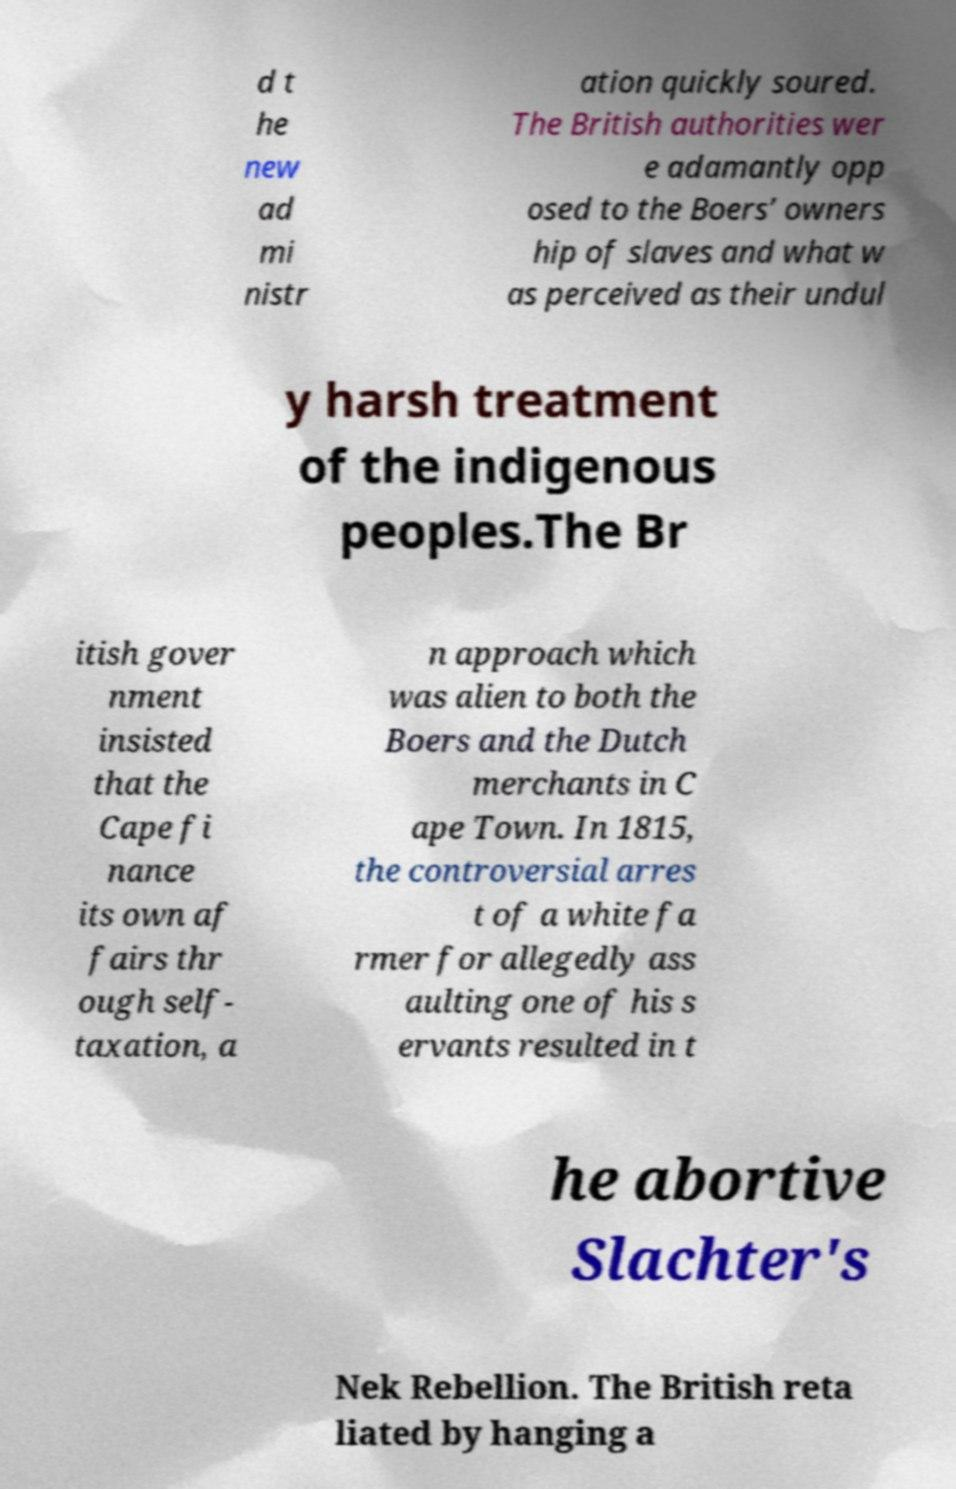For documentation purposes, I need the text within this image transcribed. Could you provide that? d t he new ad mi nistr ation quickly soured. The British authorities wer e adamantly opp osed to the Boers’ owners hip of slaves and what w as perceived as their undul y harsh treatment of the indigenous peoples.The Br itish gover nment insisted that the Cape fi nance its own af fairs thr ough self- taxation, a n approach which was alien to both the Boers and the Dutch merchants in C ape Town. In 1815, the controversial arres t of a white fa rmer for allegedly ass aulting one of his s ervants resulted in t he abortive Slachter's Nek Rebellion. The British reta liated by hanging a 